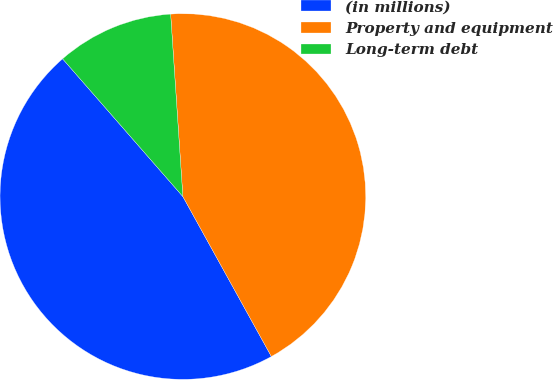Convert chart to OTSL. <chart><loc_0><loc_0><loc_500><loc_500><pie_chart><fcel>(in millions)<fcel>Property and equipment<fcel>Long-term debt<nl><fcel>46.62%<fcel>43.02%<fcel>10.36%<nl></chart> 